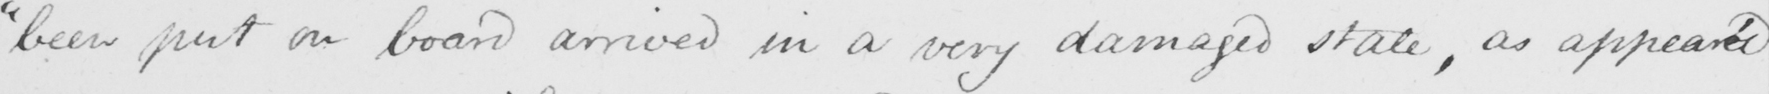Please provide the text content of this handwritten line. " been put on board arrived in a very damaged state , as appear ' d 